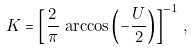Convert formula to latex. <formula><loc_0><loc_0><loc_500><loc_500>K = \left [ \frac { 2 } { \pi } \, \arccos \left ( - \frac { U } { 2 } \right ) \right ] ^ { - 1 } \, ,</formula> 